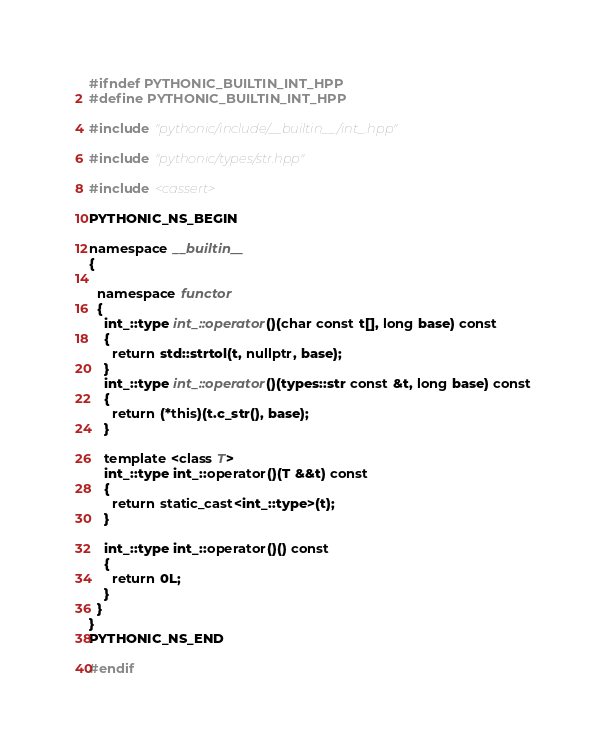<code> <loc_0><loc_0><loc_500><loc_500><_C++_>#ifndef PYTHONIC_BUILTIN_INT_HPP
#define PYTHONIC_BUILTIN_INT_HPP

#include "pythonic/include/__builtin__/int_.hpp"

#include "pythonic/types/str.hpp"

#include <cassert>

PYTHONIC_NS_BEGIN

namespace __builtin__
{

  namespace functor
  {
    int_::type int_::operator()(char const t[], long base) const
    {
      return std::strtol(t, nullptr, base);
    }
    int_::type int_::operator()(types::str const &t, long base) const
    {
      return (*this)(t.c_str(), base);
    }

    template <class T>
    int_::type int_::operator()(T &&t) const
    {
      return static_cast<int_::type>(t);
    }

    int_::type int_::operator()() const
    {
      return 0L;
    }
  }
}
PYTHONIC_NS_END

#endif
</code> 